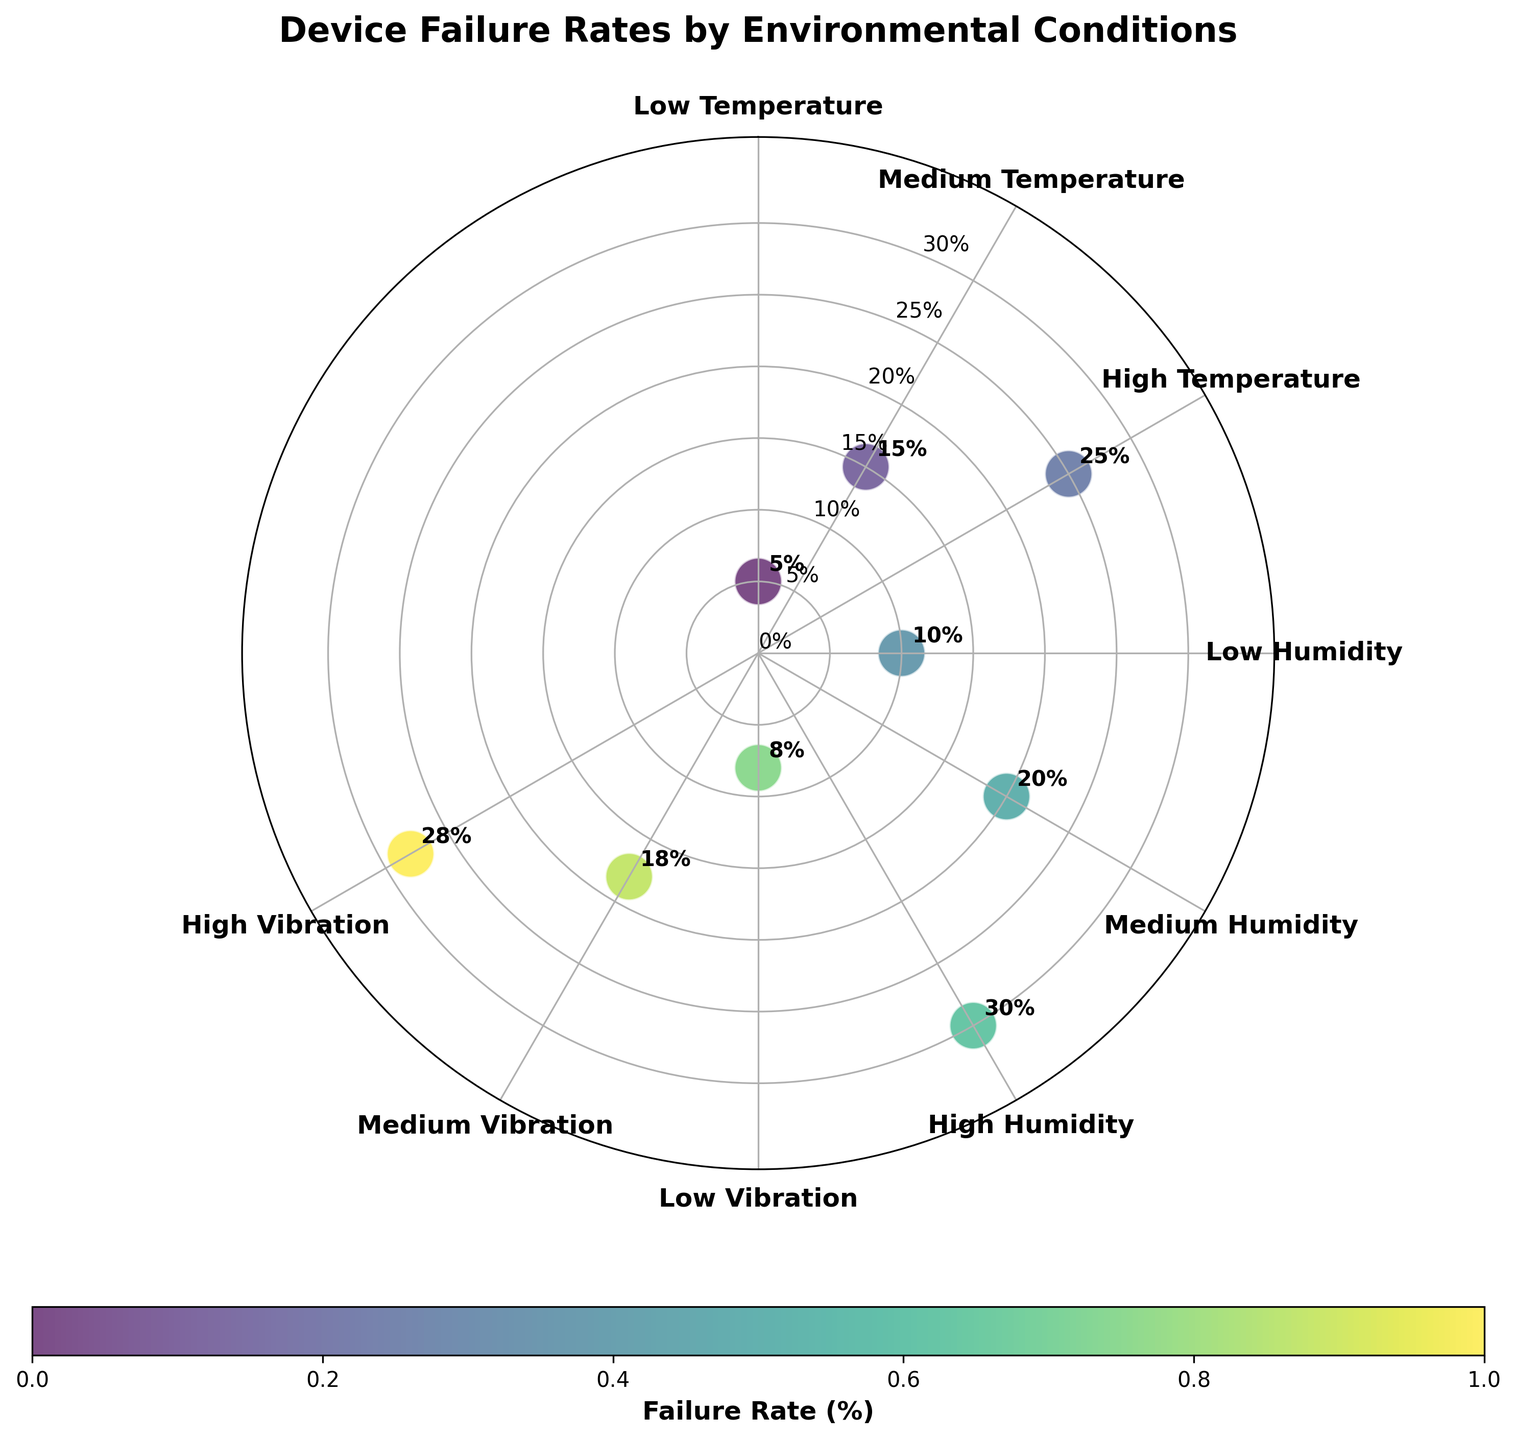Which environmental condition has the highest device failure rate? To determine this, look for the point farthest from the center on the radial axis. The highest point corresponds to the "High Humidity" condition.
Answer: High Humidity What is the failure rate for Low Vibration conditions? Locate the point labeled "Low Vibration" along the 180-degree line and read its radial value.
Answer: 8% Which environmental conditions have a failure rate above 20%? Identify the points that lie above the 20% mark on the radial axis. The conditions are "High Humidity" and "High Vibration."
Answer: High Humidity and High Vibration How many environmental conditions have a failure rate below 10%? Find all data points with a radial value less than 10%. These are "Low Temperature" and "Low Vibration."
Answer: 2 What is the difference in failure rates between Medium Temperature and Medium Humidity? Identify the failure rates for "Medium Temperature" (15%) and "Medium Humidity" (20%), then calculate the difference.
Answer: 5% Which environmental condition has a higher failure rate: Low Humidity or Medium Temperature? Compare the failure rates for "Low Humidity" (10%) and "Medium Temperature" (15%).
Answer: Medium Temperature What is the average failure rate of conditions related to humidity? Sum the failure rates for "Low Humidity" (10%), "Medium Humidity" (20%), and "High Humidity" (30%), then divide by the number of conditions.
Answer: 20% At which angle is the failure rate for High Vibration conditions plotted? Locate the "High Vibration" point and check its angular position.
Answer: 240 degrees What is the range of failure rates observed in the figure? Identify the minimum (5%) and maximum (30%) failure rates, then calculate the range by subtracting the minimum from the maximum.
Answer: 25% Which environmental conditions have a failure rate between 15% and 25%? Find data points with radial values between 15% and 25%. These are "Medium Temperature," "Medium Humidity," and "High Temperature."
Answer: Medium Temperature, Medium Humidity, and High Temperature 